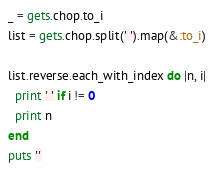Convert code to text. <code><loc_0><loc_0><loc_500><loc_500><_Ruby_>_ = gets.chop.to_i
list = gets.chop.split(' ').map(&:to_i)

list.reverse.each_with_index do |n, i|
  print ' ' if i != 0
  print n
end
puts ''

</code> 